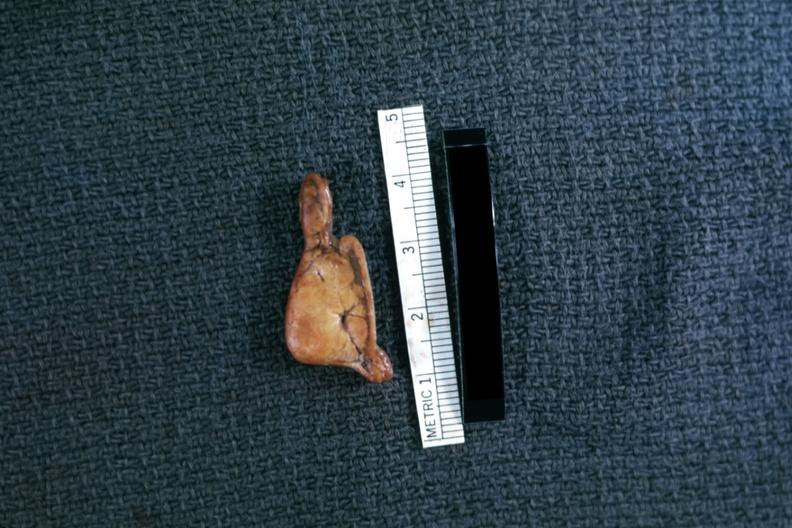what is present?
Answer the question using a single word or phrase. Adrenal 